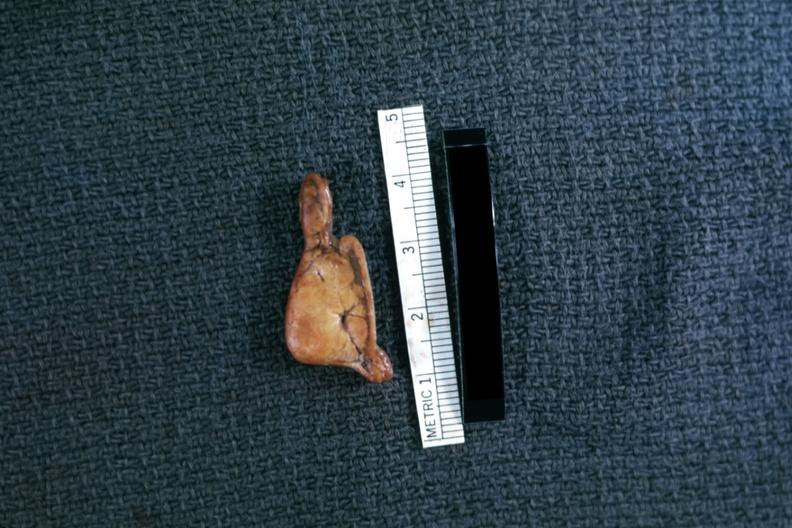what is present?
Answer the question using a single word or phrase. Adrenal 